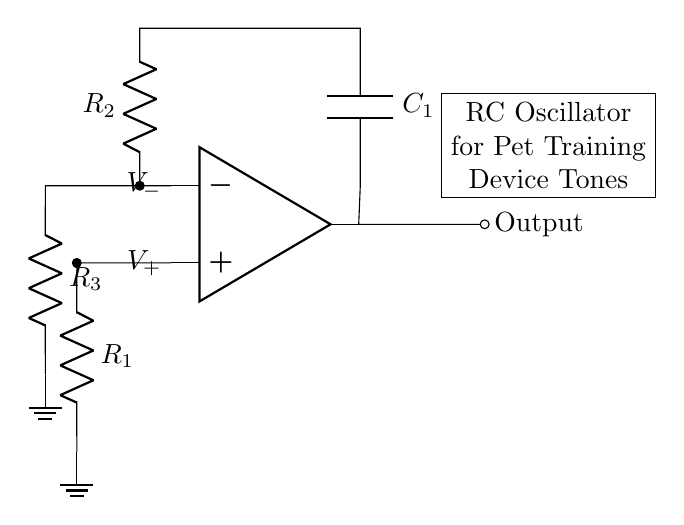What type of operational amplifier configuration is used in this oscillator? The circuit uses a feedback configuration where the output is connected back to the inverting input through resistors and capacitor, typically a non-inverting configuration.
Answer: Feedback What is the role of the capacitor in this circuit? The capacitor is responsible for creating the timing characteristics of the oscillator, influencing the frequency of oscillation by charging and discharging through the resistors.
Answer: Timing How many resistors are used in this RC oscillator circuit? There are three resistors present in the circuit, labeled as R1, R2, and R3.
Answer: Three Which component controls the output frequency of the oscillator? The output frequency is primarily controlled by the resistor R2 and capacitor C1, as they define the charge and discharge rates.
Answer: R2 and C1 What is the primary output of this circuit intended for? The primary output is intended to generate audible tones for pet training devices, aiding in communication during training.
Answer: Audible tones What does the label "RC Oscillator" indicate about this circuit? The label indicates that this circuit is designed to oscillate based on the resistive and capacitive components, producing periodic waveforms.
Answer: Oscillation Why is the ground connection important in this circuit? The ground connection serves as a reference point for the circuit, ensuring that all voltages are measured relative to a common reference point, which is crucial for the correct operation of the circuit.
Answer: Reference point 